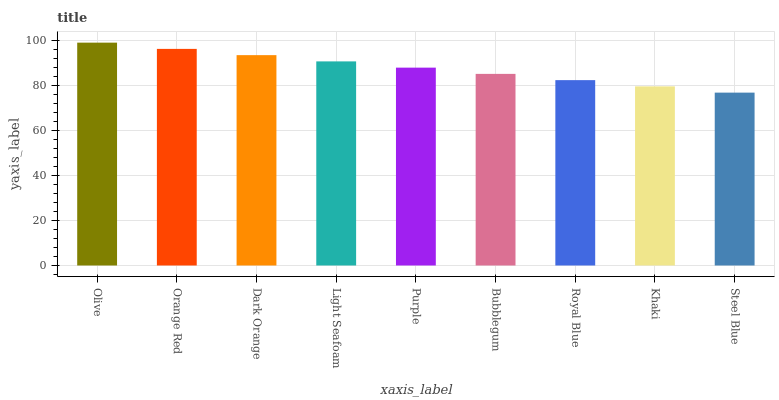Is Steel Blue the minimum?
Answer yes or no. Yes. Is Olive the maximum?
Answer yes or no. Yes. Is Orange Red the minimum?
Answer yes or no. No. Is Orange Red the maximum?
Answer yes or no. No. Is Olive greater than Orange Red?
Answer yes or no. Yes. Is Orange Red less than Olive?
Answer yes or no. Yes. Is Orange Red greater than Olive?
Answer yes or no. No. Is Olive less than Orange Red?
Answer yes or no. No. Is Purple the high median?
Answer yes or no. Yes. Is Purple the low median?
Answer yes or no. Yes. Is Royal Blue the high median?
Answer yes or no. No. Is Olive the low median?
Answer yes or no. No. 